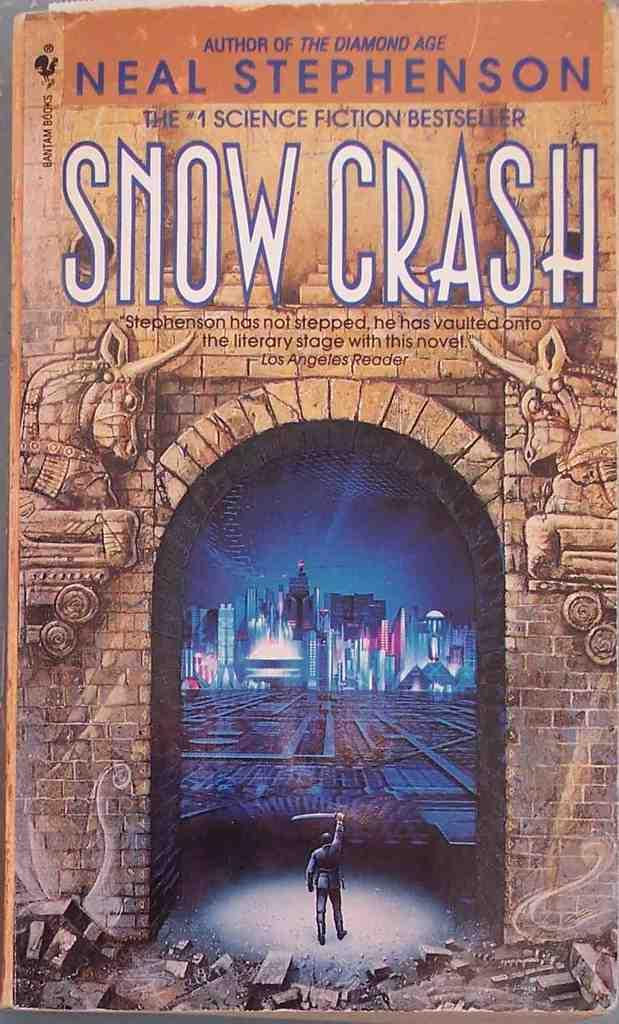<image>
Present a compact description of the photo's key features. A book by neal stephenson titled snow crash 